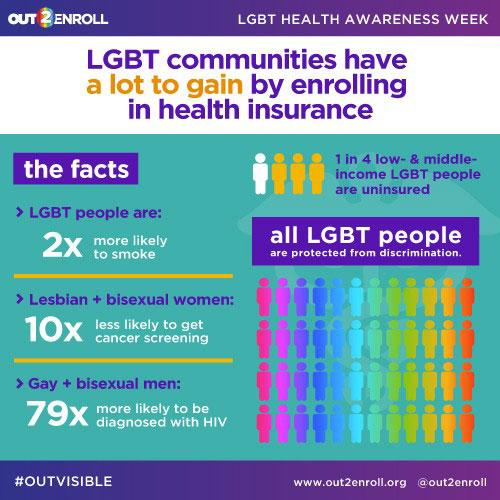Identify some key points in this picture. LGBT individuals are twice as likely to smoke as non-LGBT individuals. 